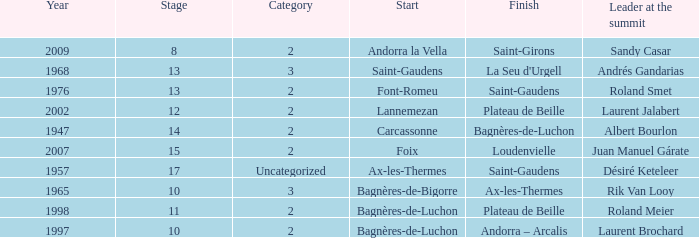Give the Finish for years after 2007. Saint-Girons. Parse the full table. {'header': ['Year', 'Stage', 'Category', 'Start', 'Finish', 'Leader at the summit'], 'rows': [['2009', '8', '2', 'Andorra la Vella', 'Saint-Girons', 'Sandy Casar'], ['1968', '13', '3', 'Saint-Gaudens', "La Seu d'Urgell", 'Andrés Gandarias'], ['1976', '13', '2', 'Font-Romeu', 'Saint-Gaudens', 'Roland Smet'], ['2002', '12', '2', 'Lannemezan', 'Plateau de Beille', 'Laurent Jalabert'], ['1947', '14', '2', 'Carcassonne', 'Bagnères-de-Luchon', 'Albert Bourlon'], ['2007', '15', '2', 'Foix', 'Loudenvielle', 'Juan Manuel Gárate'], ['1957', '17', 'Uncategorized', 'Ax-les-Thermes', 'Saint-Gaudens', 'Désiré Keteleer'], ['1965', '10', '3', 'Bagnères-de-Bigorre', 'Ax-les-Thermes', 'Rik Van Looy'], ['1998', '11', '2', 'Bagnères-de-Luchon', 'Plateau de Beille', 'Roland Meier'], ['1997', '10', '2', 'Bagnères-de-Luchon', 'Andorra – Arcalis', 'Laurent Brochard']]} 